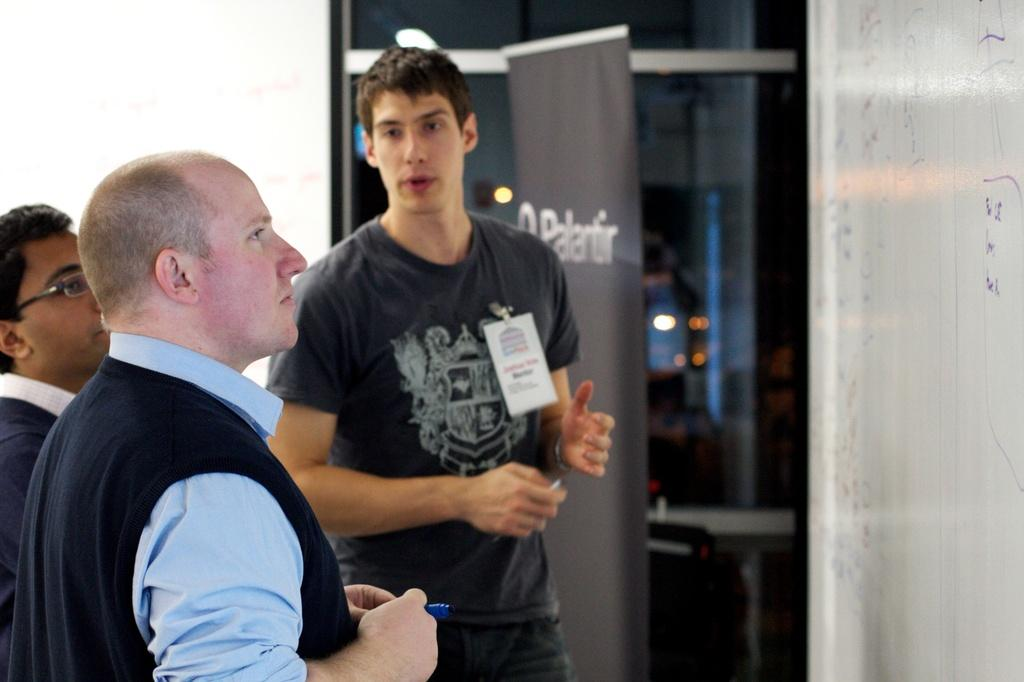What are the three people in the image doing? The three people in the image are standing and talking to each other. What is in front of the people? There is a board in front of the people. What can be seen in the background of the image? There is a banner, a glass window, and a wall in the background. What type of cloud can be seen in the bedroom in the image? There is no bedroom or cloud present in the image. 